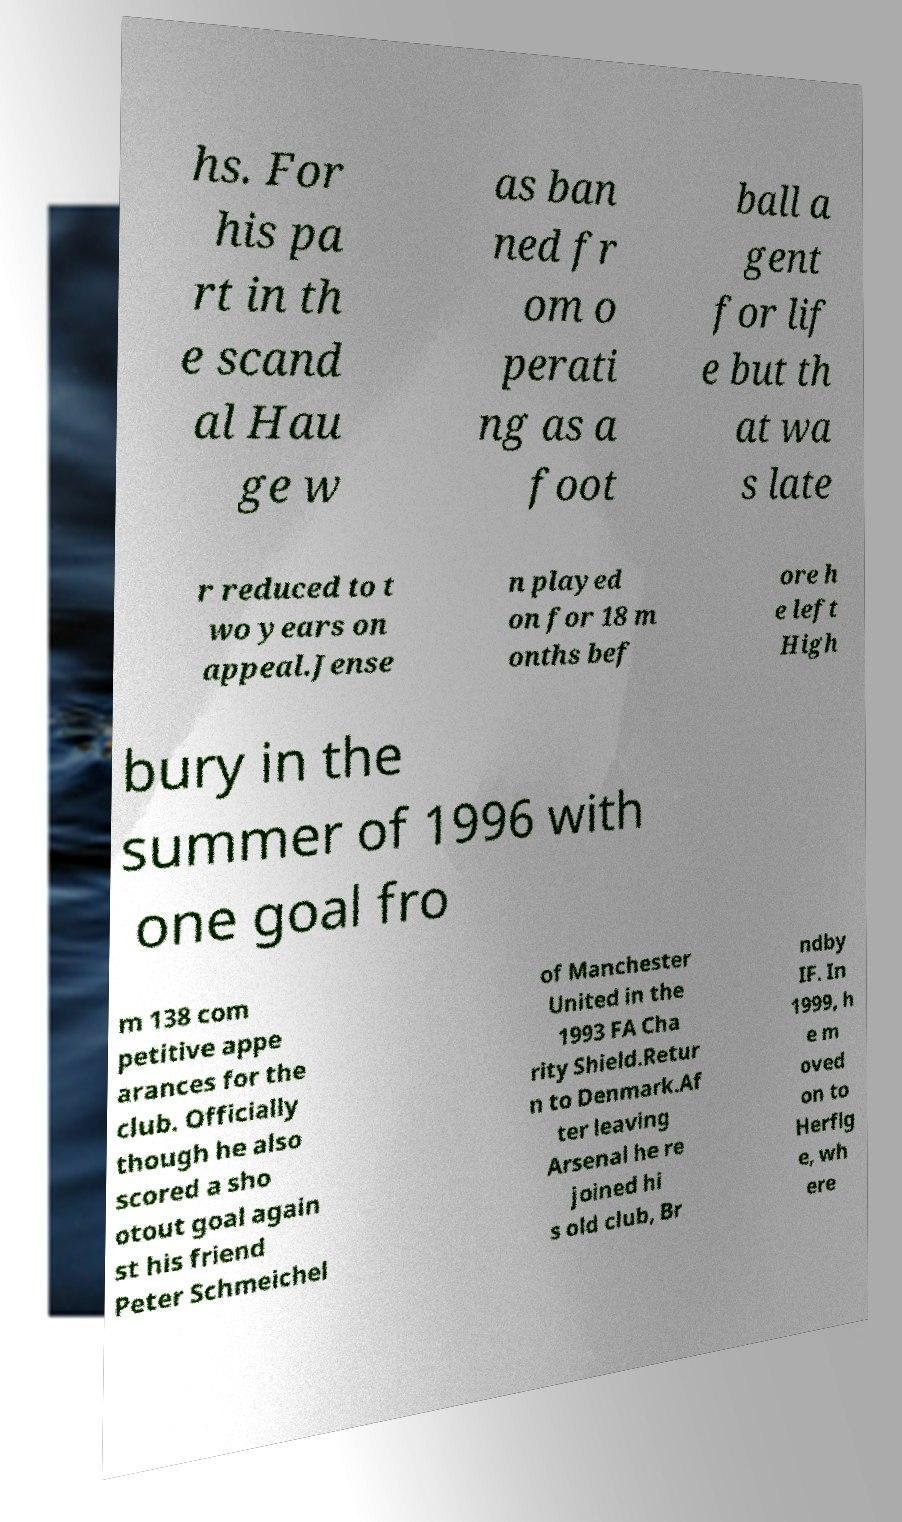What is the significance of the 'scandal' mentioned in the text? The 'scandal' mentioned in the text refers to a situation involving Hauge, who was banned from operating as a football agent. This often implies some unethical or controversial activities within sports management, affecting careers and regulations in football. 